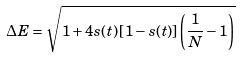<formula> <loc_0><loc_0><loc_500><loc_500>\Delta E = \sqrt { 1 + 4 s ( t ) \left [ 1 - s ( t ) \right ] \left ( \frac { 1 } { N } - 1 \right ) }</formula> 